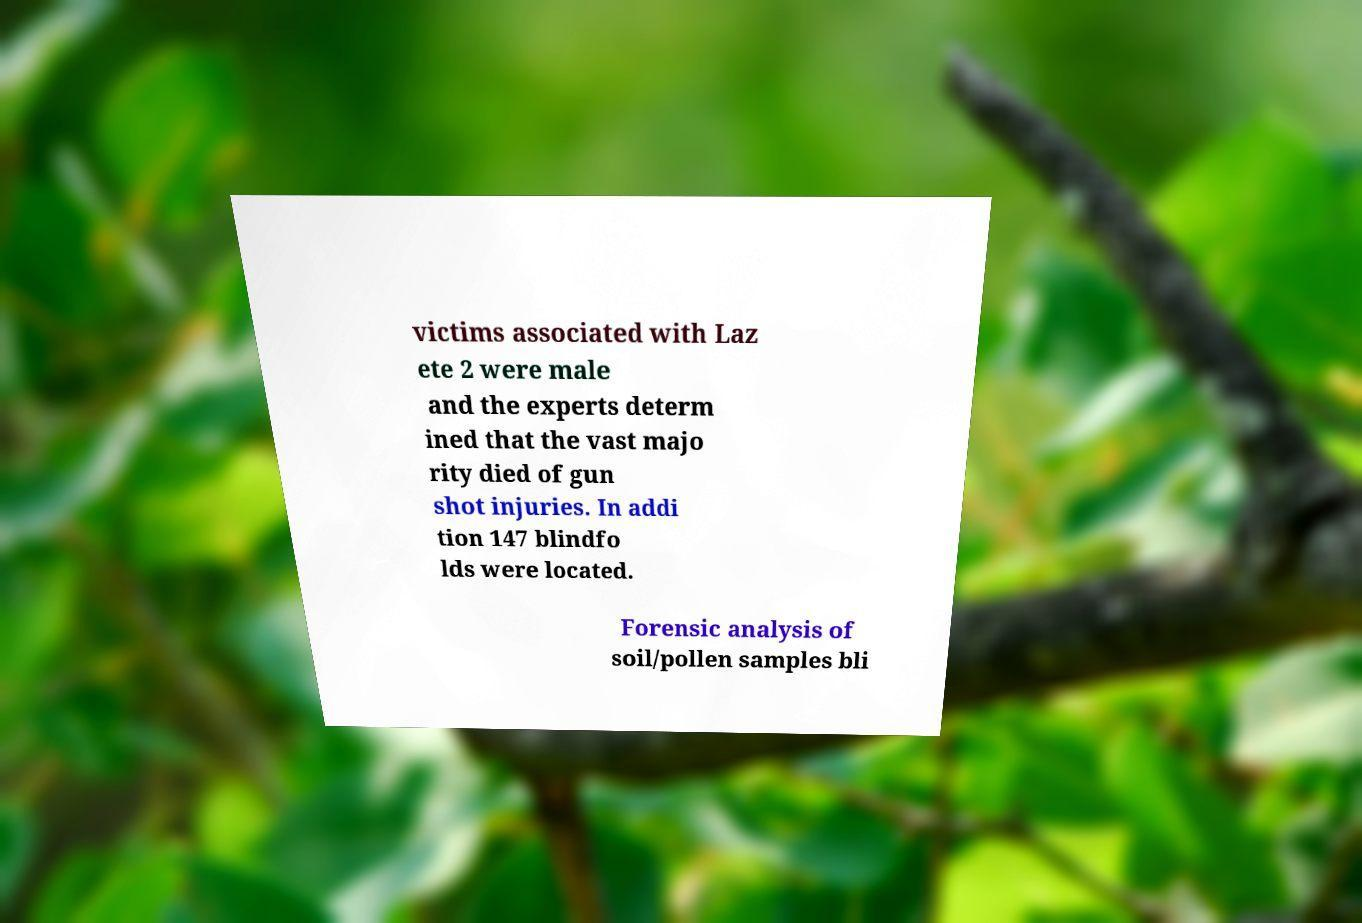What messages or text are displayed in this image? I need them in a readable, typed format. victims associated with Laz ete 2 were male and the experts determ ined that the vast majo rity died of gun shot injuries. In addi tion 147 blindfo lds were located. Forensic analysis of soil/pollen samples bli 